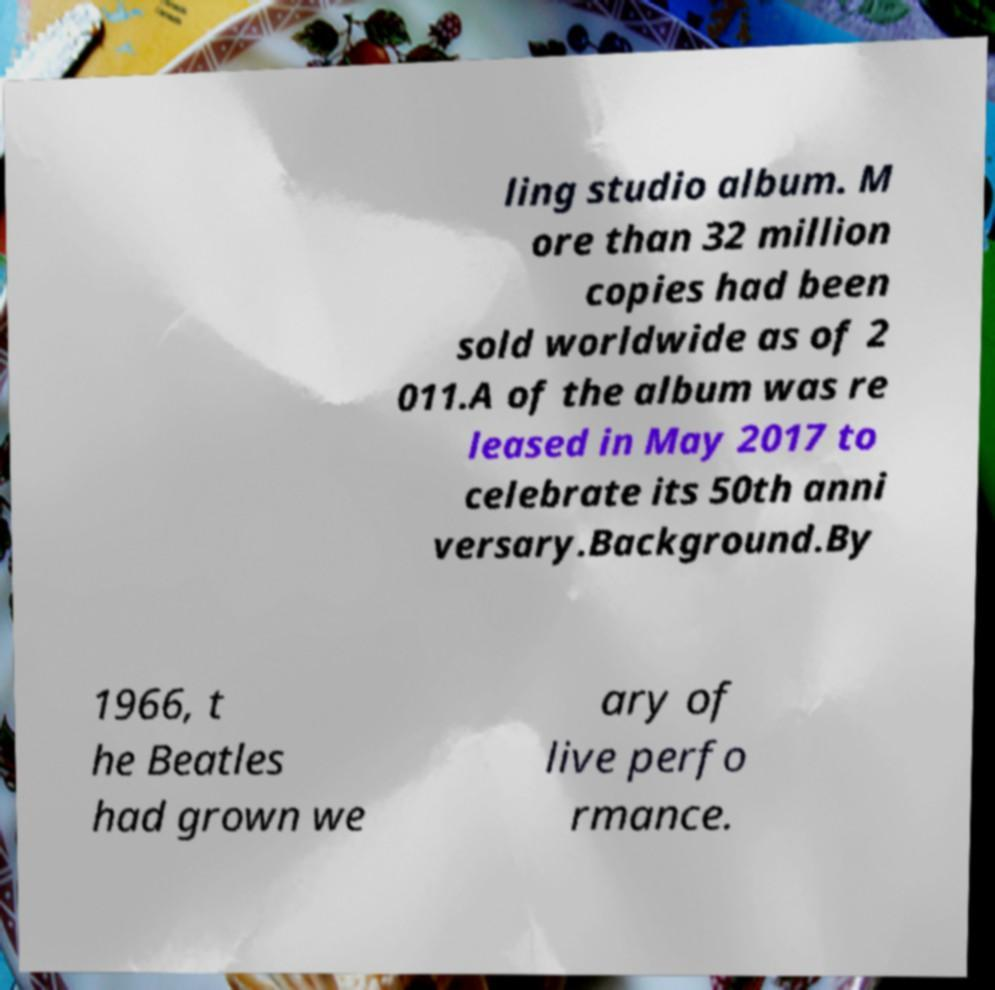Can you read and provide the text displayed in the image?This photo seems to have some interesting text. Can you extract and type it out for me? ling studio album. M ore than 32 million copies had been sold worldwide as of 2 011.A of the album was re leased in May 2017 to celebrate its 50th anni versary.Background.By 1966, t he Beatles had grown we ary of live perfo rmance. 